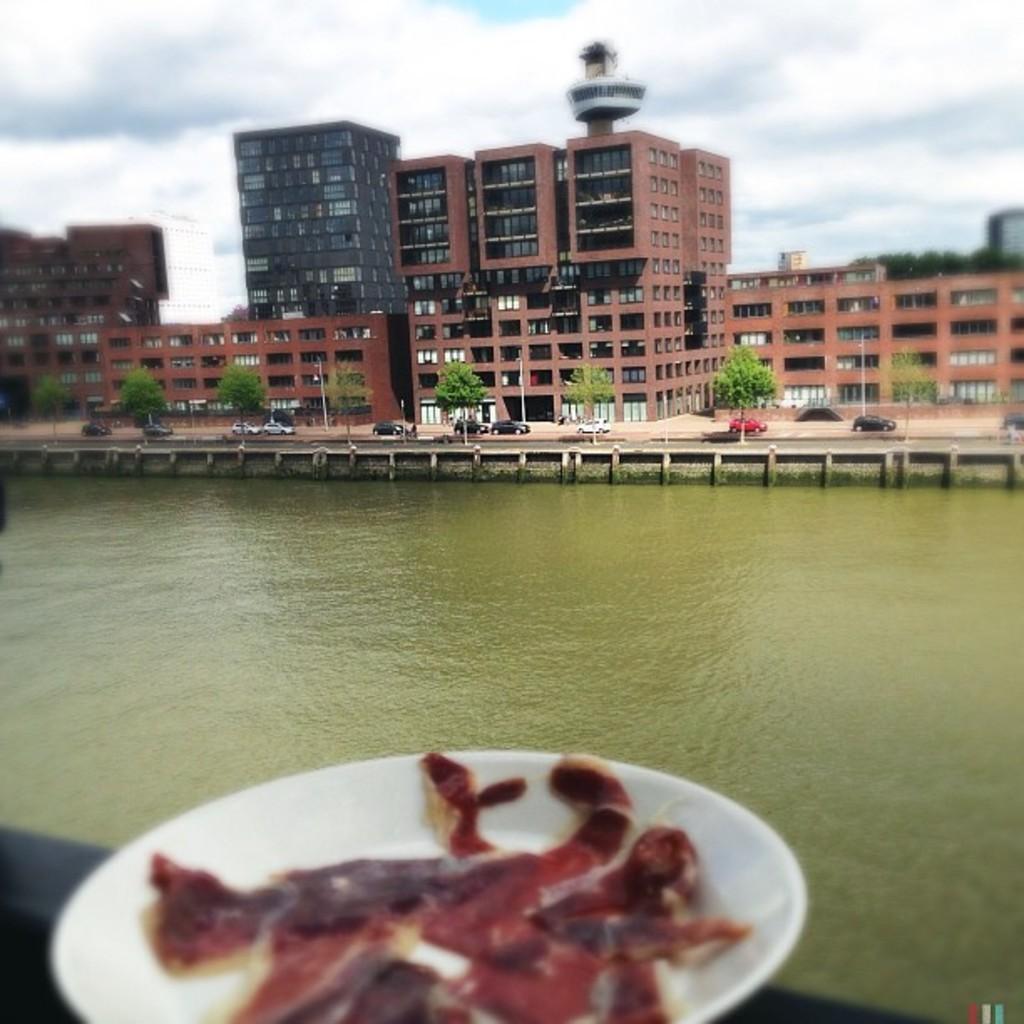Can you describe this image briefly? There is a white color plate having some objects on it. This plate is on the wall. In the background, there is water, there are vehicles on the road, there are trees, buildings and there are clouds in the blue sky. 